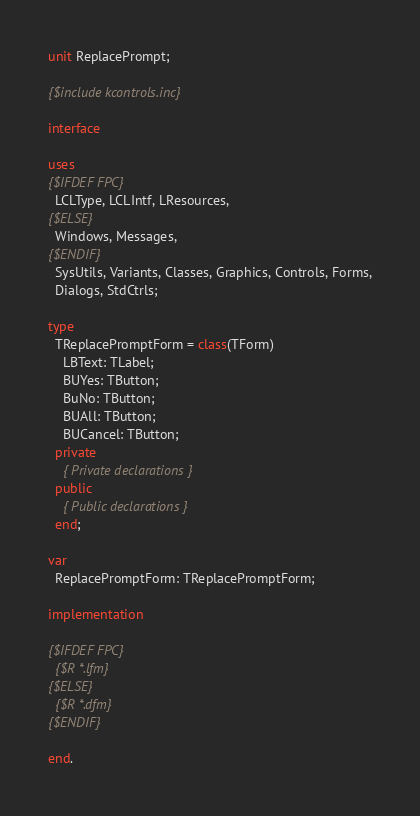Convert code to text. <code><loc_0><loc_0><loc_500><loc_500><_Pascal_>unit ReplacePrompt;

{$include kcontrols.inc}

interface

uses
{$IFDEF FPC}
  LCLType, LCLIntf, LResources,
{$ELSE}
  Windows, Messages,
{$ENDIF}
  SysUtils, Variants, Classes, Graphics, Controls, Forms,
  Dialogs, StdCtrls;

type
  TReplacePromptForm = class(TForm)
    LBText: TLabel;
    BUYes: TButton;
    BuNo: TButton;
    BUAll: TButton;
    BUCancel: TButton;
  private
    { Private declarations }
  public
    { Public declarations }
  end;

var
  ReplacePromptForm: TReplacePromptForm;

implementation

{$IFDEF FPC}
  {$R *.lfm}
{$ELSE}
  {$R *.dfm}
{$ENDIF}

end.
</code> 